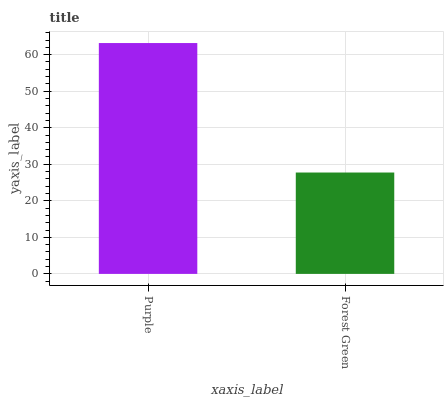Is Forest Green the minimum?
Answer yes or no. Yes. Is Purple the maximum?
Answer yes or no. Yes. Is Forest Green the maximum?
Answer yes or no. No. Is Purple greater than Forest Green?
Answer yes or no. Yes. Is Forest Green less than Purple?
Answer yes or no. Yes. Is Forest Green greater than Purple?
Answer yes or no. No. Is Purple less than Forest Green?
Answer yes or no. No. Is Purple the high median?
Answer yes or no. Yes. Is Forest Green the low median?
Answer yes or no. Yes. Is Forest Green the high median?
Answer yes or no. No. Is Purple the low median?
Answer yes or no. No. 